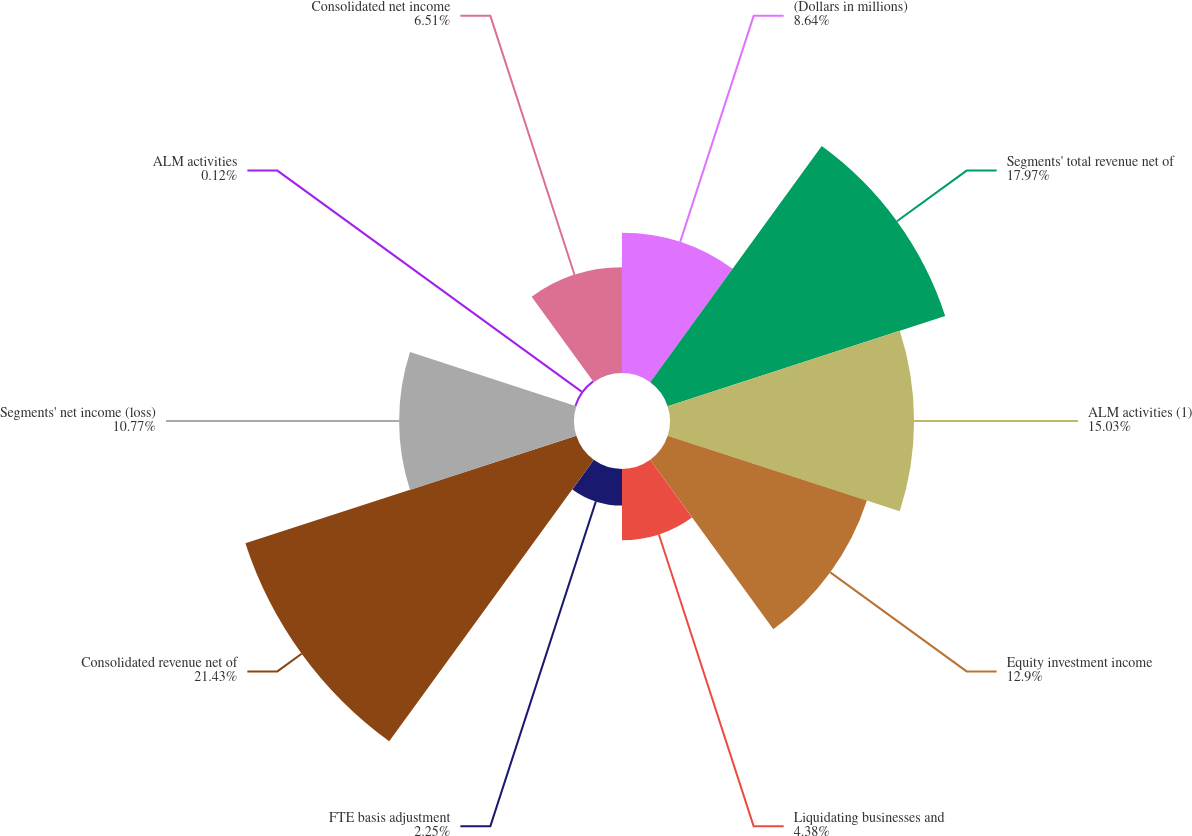Convert chart. <chart><loc_0><loc_0><loc_500><loc_500><pie_chart><fcel>(Dollars in millions)<fcel>Segments' total revenue net of<fcel>ALM activities (1)<fcel>Equity investment income<fcel>Liquidating businesses and<fcel>FTE basis adjustment<fcel>Consolidated revenue net of<fcel>Segments' net income (loss)<fcel>ALM activities<fcel>Consolidated net income<nl><fcel>8.64%<fcel>17.97%<fcel>15.03%<fcel>12.9%<fcel>4.38%<fcel>2.25%<fcel>21.43%<fcel>10.77%<fcel>0.12%<fcel>6.51%<nl></chart> 